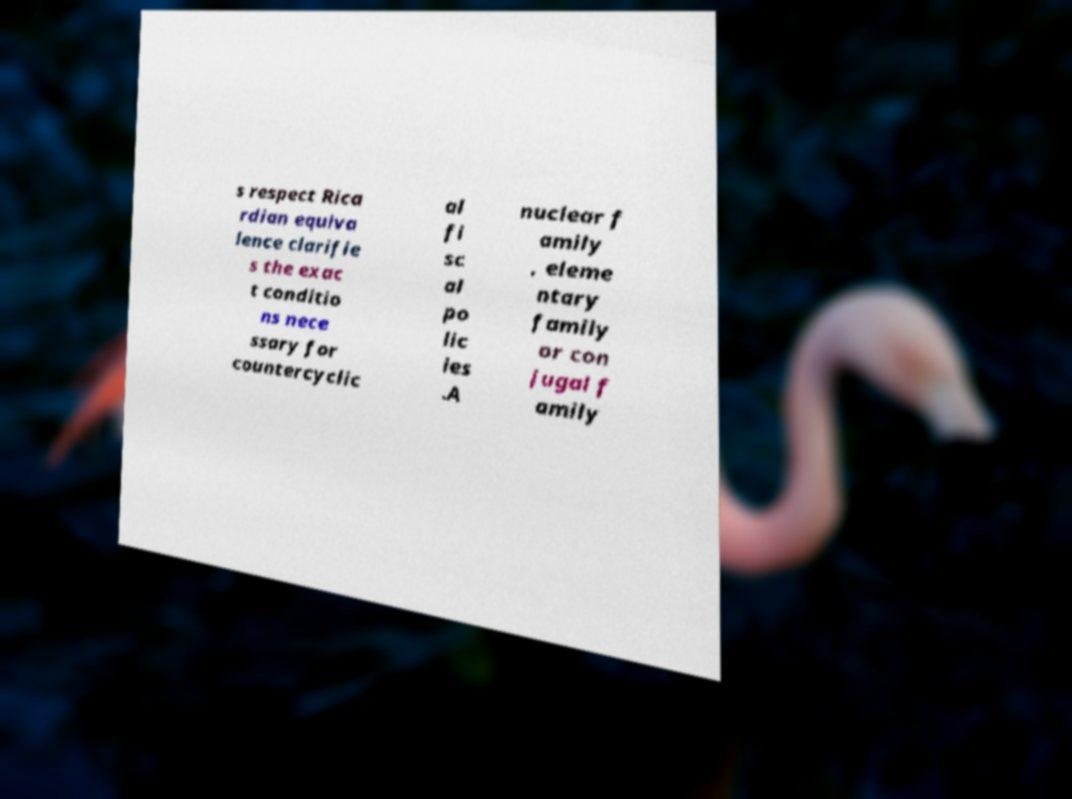I need the written content from this picture converted into text. Can you do that? s respect Rica rdian equiva lence clarifie s the exac t conditio ns nece ssary for countercyclic al fi sc al po lic ies .A nuclear f amily , eleme ntary family or con jugal f amily 